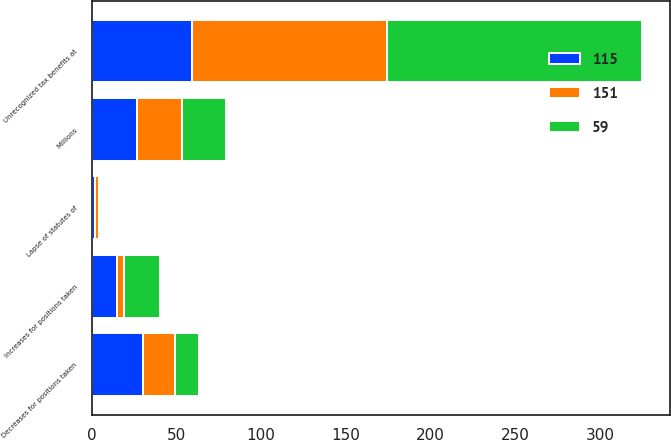Convert chart. <chart><loc_0><loc_0><loc_500><loc_500><stacked_bar_chart><ecel><fcel>Millions<fcel>Unrecognized tax benefits at<fcel>Increases for positions taken<fcel>Decreases for positions taken<fcel>Lapse of statutes of<nl><fcel>59<fcel>26.5<fcel>151<fcel>21<fcel>14<fcel>1<nl><fcel>115<fcel>26.5<fcel>59<fcel>15<fcel>30<fcel>2<nl><fcel>151<fcel>26.5<fcel>115<fcel>4<fcel>19<fcel>2<nl></chart> 